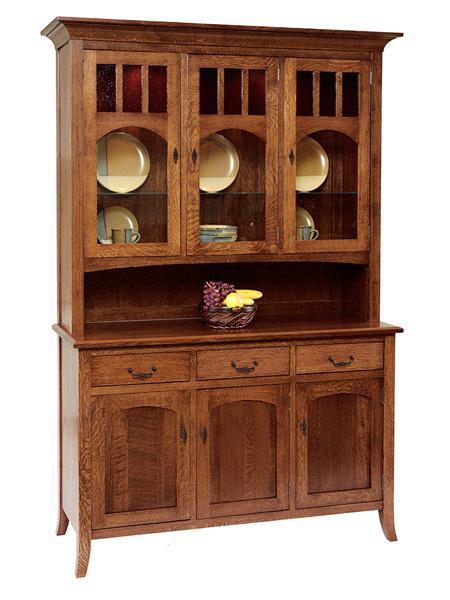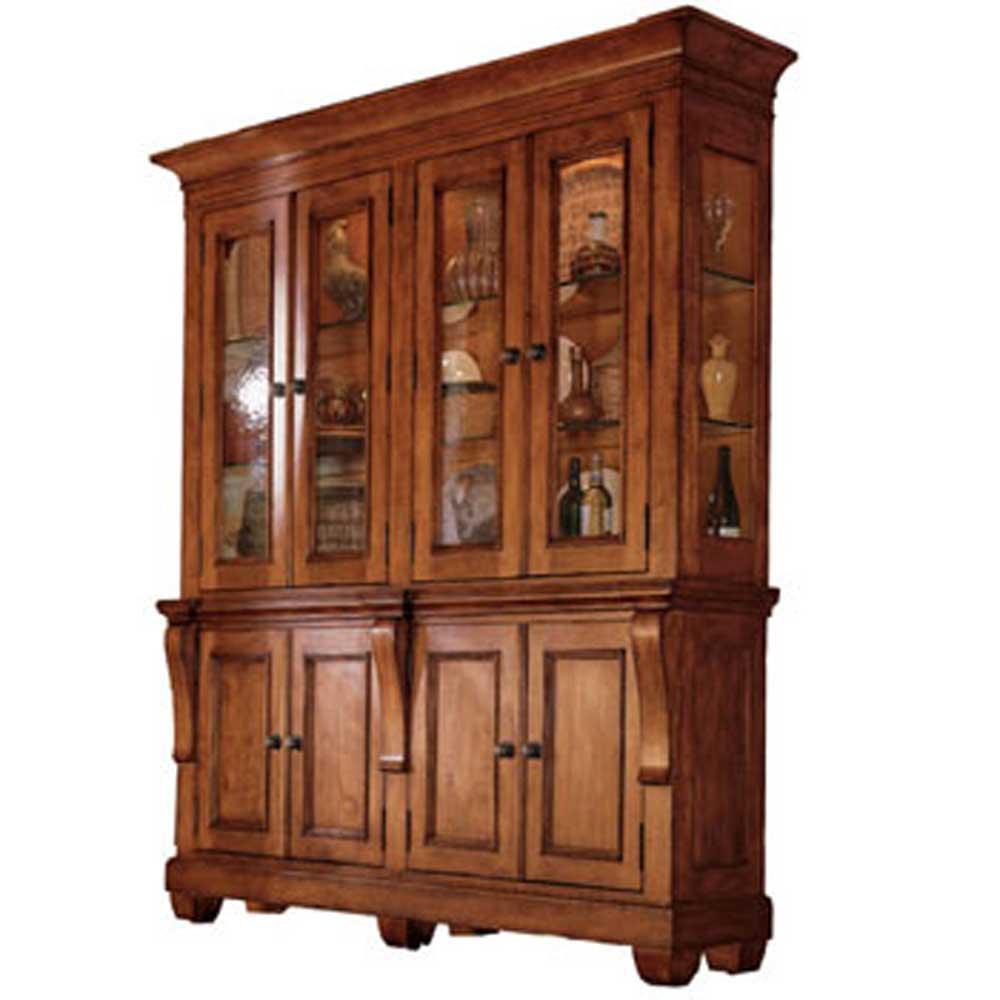The first image is the image on the left, the second image is the image on the right. For the images displayed, is the sentence "A brown hutch is empty in the right image." factually correct? Answer yes or no. No. 